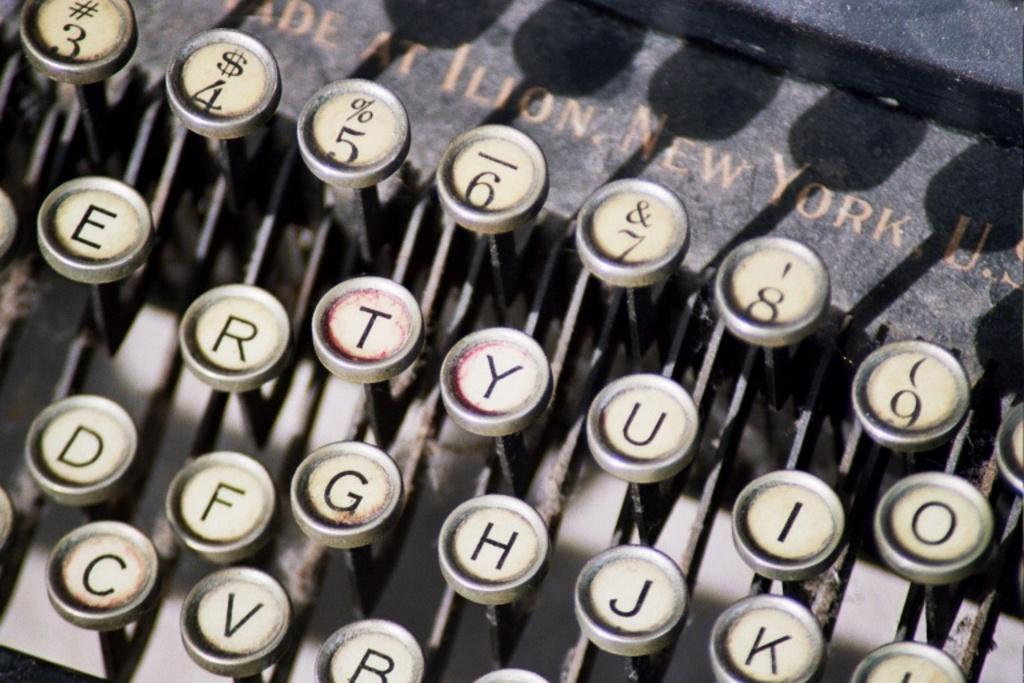<image>
Summarize the visual content of the image. A really old typewriter that says New York on it and has several keys showing such as T, Y, U, O, I, and R. 